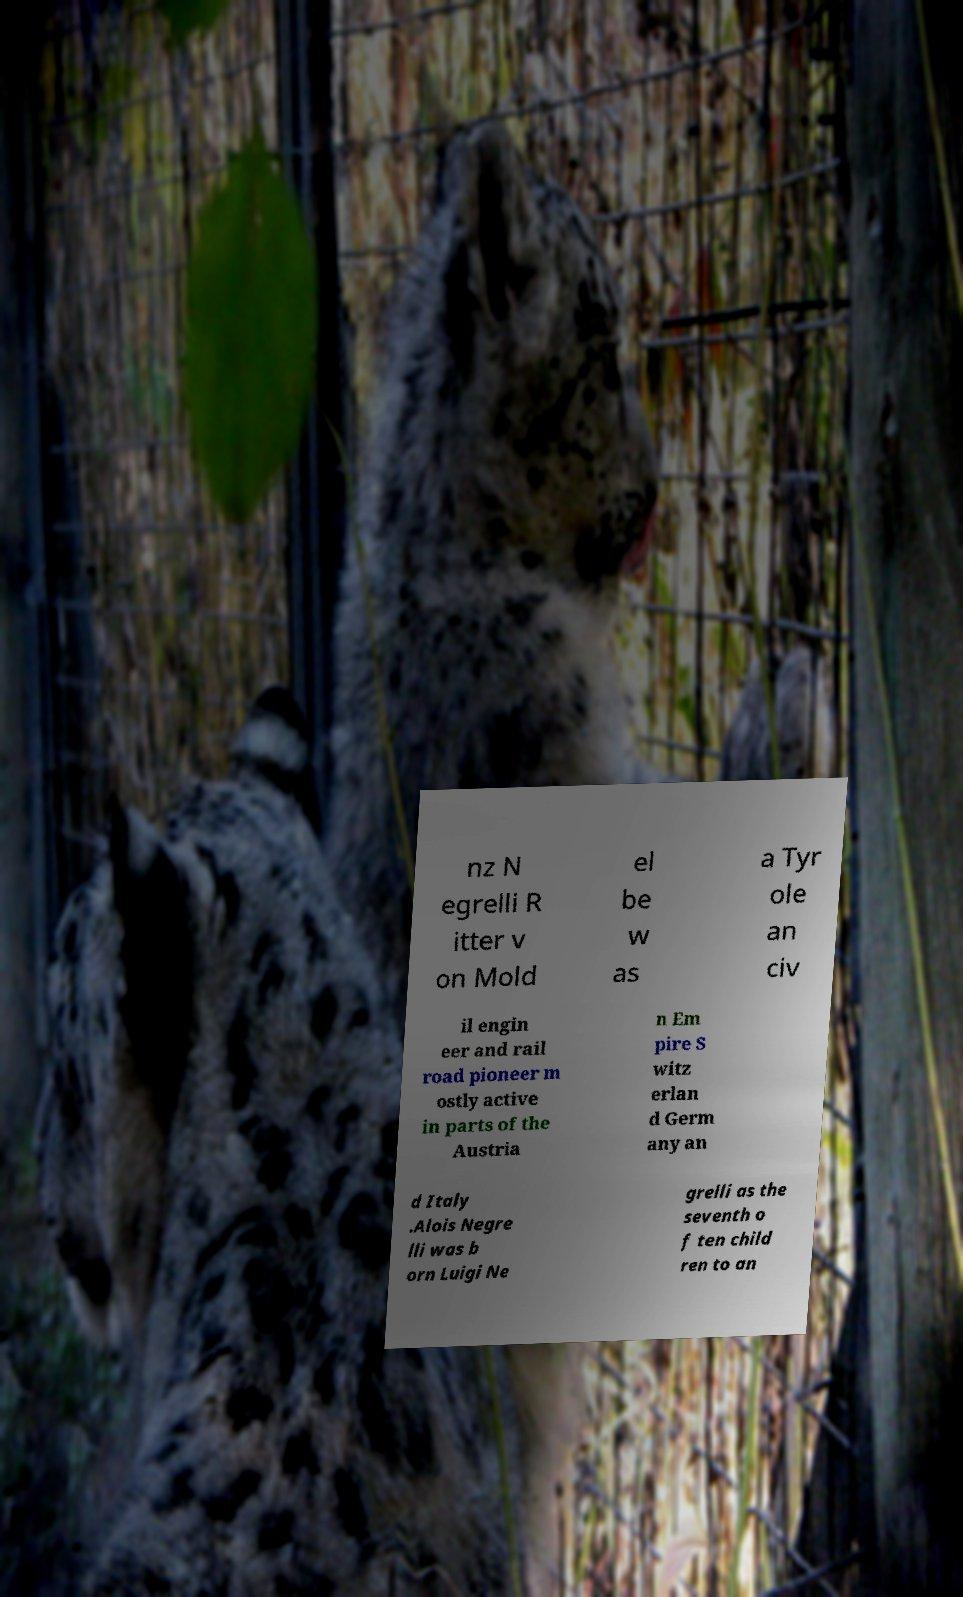Could you extract and type out the text from this image? nz N egrelli R itter v on Mold el be w as a Tyr ole an civ il engin eer and rail road pioneer m ostly active in parts of the Austria n Em pire S witz erlan d Germ any an d Italy .Alois Negre lli was b orn Luigi Ne grelli as the seventh o f ten child ren to an 